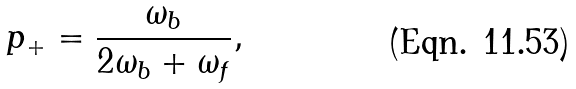Convert formula to latex. <formula><loc_0><loc_0><loc_500><loc_500>p _ { + } = \frac { \omega _ { b } } { 2 \omega _ { b } + \omega _ { f } } ,</formula> 